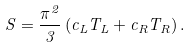Convert formula to latex. <formula><loc_0><loc_0><loc_500><loc_500>S = \frac { \pi ^ { 2 } } { 3 } \left ( c _ { L } T _ { L } + c _ { R } T _ { R } \right ) .</formula> 